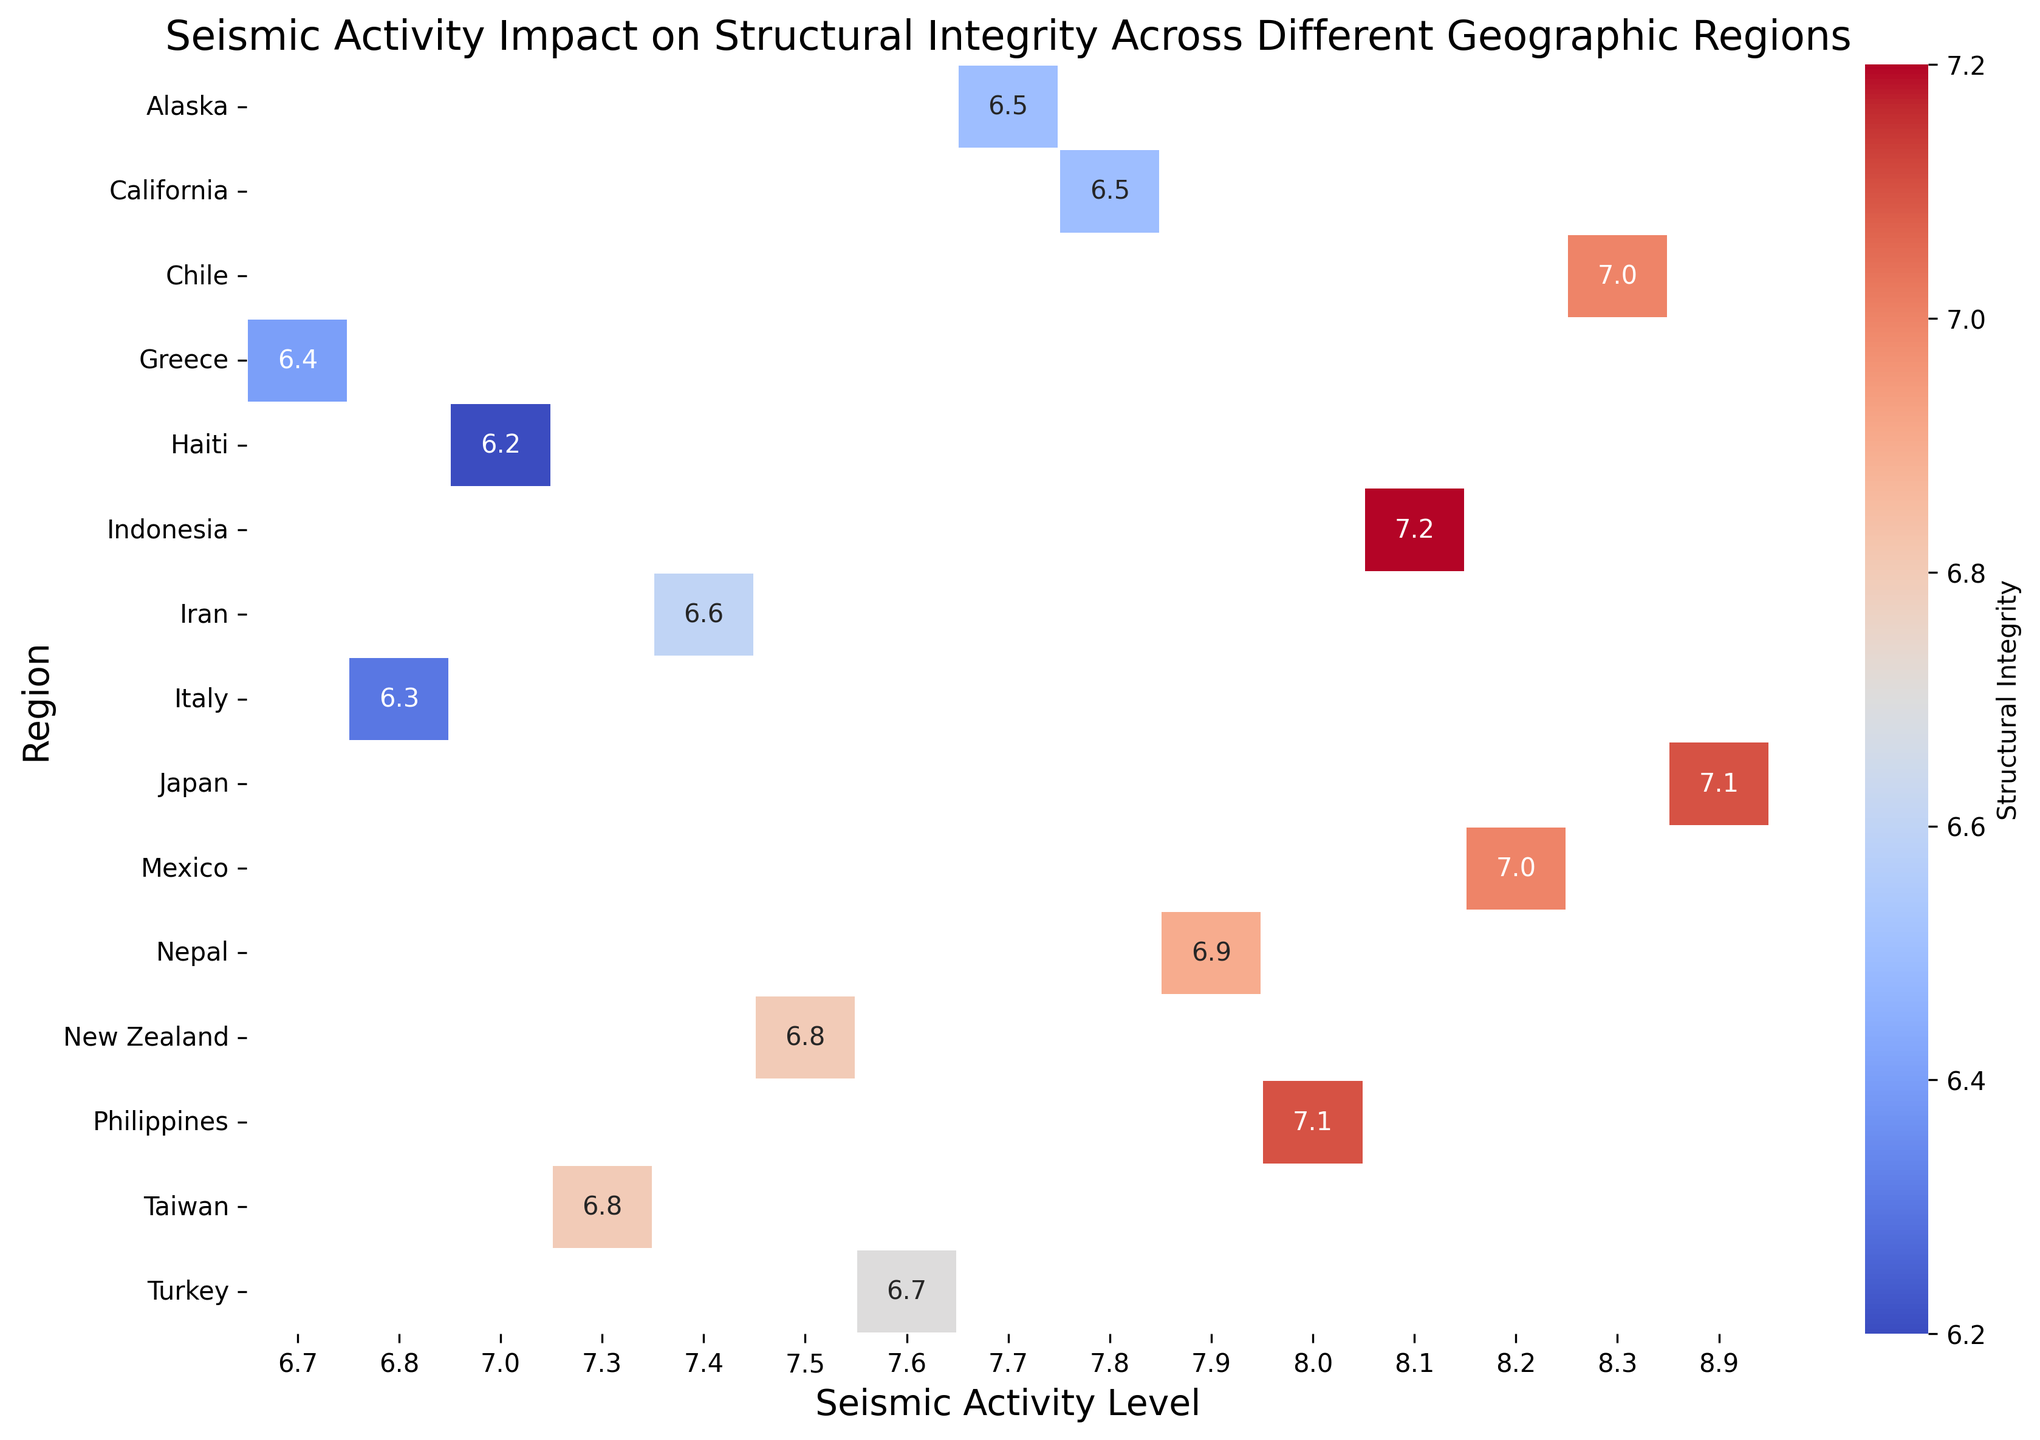What region has the highest seismic activity level? By looking at the color gradient and the annotated seismic activity levels, we can identify the highest value. The highest seismic activity level is 8.9, which corresponds to Japan.
Answer: Japan Which region shows the highest structural integrity? By examining the heatmap, the region with the highest structural integrity score, which is 7.2, is Indonesia.
Answer: Indonesia Compare the structural integrity of Japan and California. Which is higher? Looking at the heatmap, Japan has a structural integrity score of 7.1, whereas California's score is 6.5. Thus, Japan has a higher structural integrity score.
Answer: Japan What is the average structural integrity score for regions with a seismic activity level of 8.1? The regions with a seismic activity level of 8.1 are Indonesia, and the structural integrity score is 7.2. Since there is only one region, the average is simply 7.2.
Answer: 7.2 Which region has the lowest structural integrity? Observing the heatmap, the region with the lowest structural integrity score is Haiti, with a score of 6.2.
Answer: Haiti Compare the structural integrity of Mexico and Italy. Which has the lower score? According to the heatmap, Mexico has a structural integrity score of 7.0, while Italy's score is 6.3. Therefore, Italy has the lower score.
Answer: Italy What’s the average structural integrity level for regions with seismic activity levels of 7.7, 7.8, and 7.9? The regions with these seismic activity levels are Alaska (6.5), California (6.5), and Nepal (6.9). The average can be calculated as (6.5 + 6.5 + 6.9) / 3 = 6.63.
Answer: 6.63 Is there a region with a seismic activity level of 8.0, and what is its structural integrity? By checking the heatmap, Philippines has a seismic activity level of 8.0 and a structural integrity score of 7.1.
Answer: Yes, Philippines with 7.1 Which region has a higher structural integrity, Turkey or Iran? Based on the heatmap, Turkey has a structural integrity score of 6.7, whereas Iran has a score of 6.6. Therefore, Turkey has a higher score.
Answer: Turkey What is the difference in the structural integrity scores between Chile and New Zealand? The structural integrity of Chile is 7.0 and New Zealand is 6.8. The difference is 7.0 - 6.8 = 0.2.
Answer: 0.2 